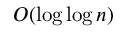<formula> <loc_0><loc_0><loc_500><loc_500>O ( \log \log n )</formula> 